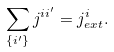<formula> <loc_0><loc_0><loc_500><loc_500>\sum _ { \{ i ^ { \prime } \} } j ^ { i i ^ { \prime } } = j _ { e x t } ^ { i } .</formula> 